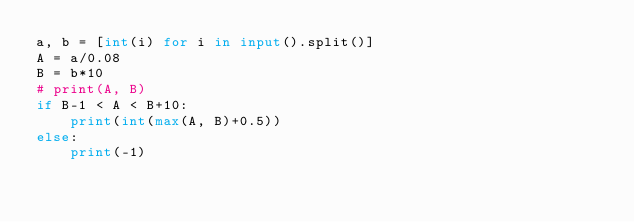<code> <loc_0><loc_0><loc_500><loc_500><_Python_>a, b = [int(i) for i in input().split()]
A = a/0.08
B = b*10
# print(A, B)
if B-1 < A < B+10:
    print(int(max(A, B)+0.5))
else:
    print(-1)
</code> 